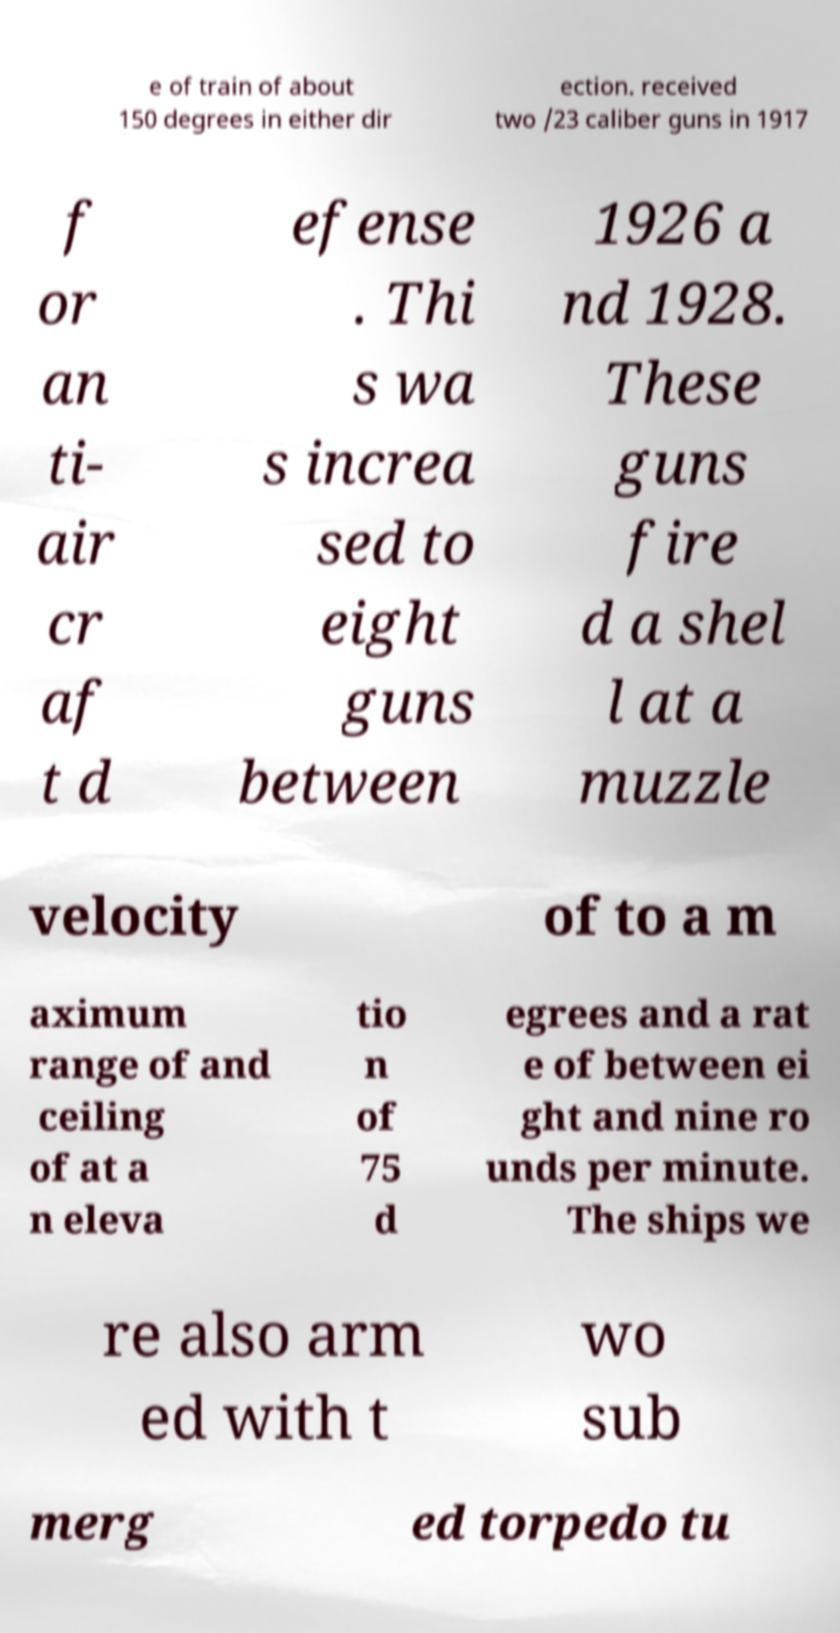Please read and relay the text visible in this image. What does it say? e of train of about 150 degrees in either dir ection. received two /23 caliber guns in 1917 f or an ti- air cr af t d efense . Thi s wa s increa sed to eight guns between 1926 a nd 1928. These guns fire d a shel l at a muzzle velocity of to a m aximum range of and ceiling of at a n eleva tio n of 75 d egrees and a rat e of between ei ght and nine ro unds per minute. The ships we re also arm ed with t wo sub merg ed torpedo tu 